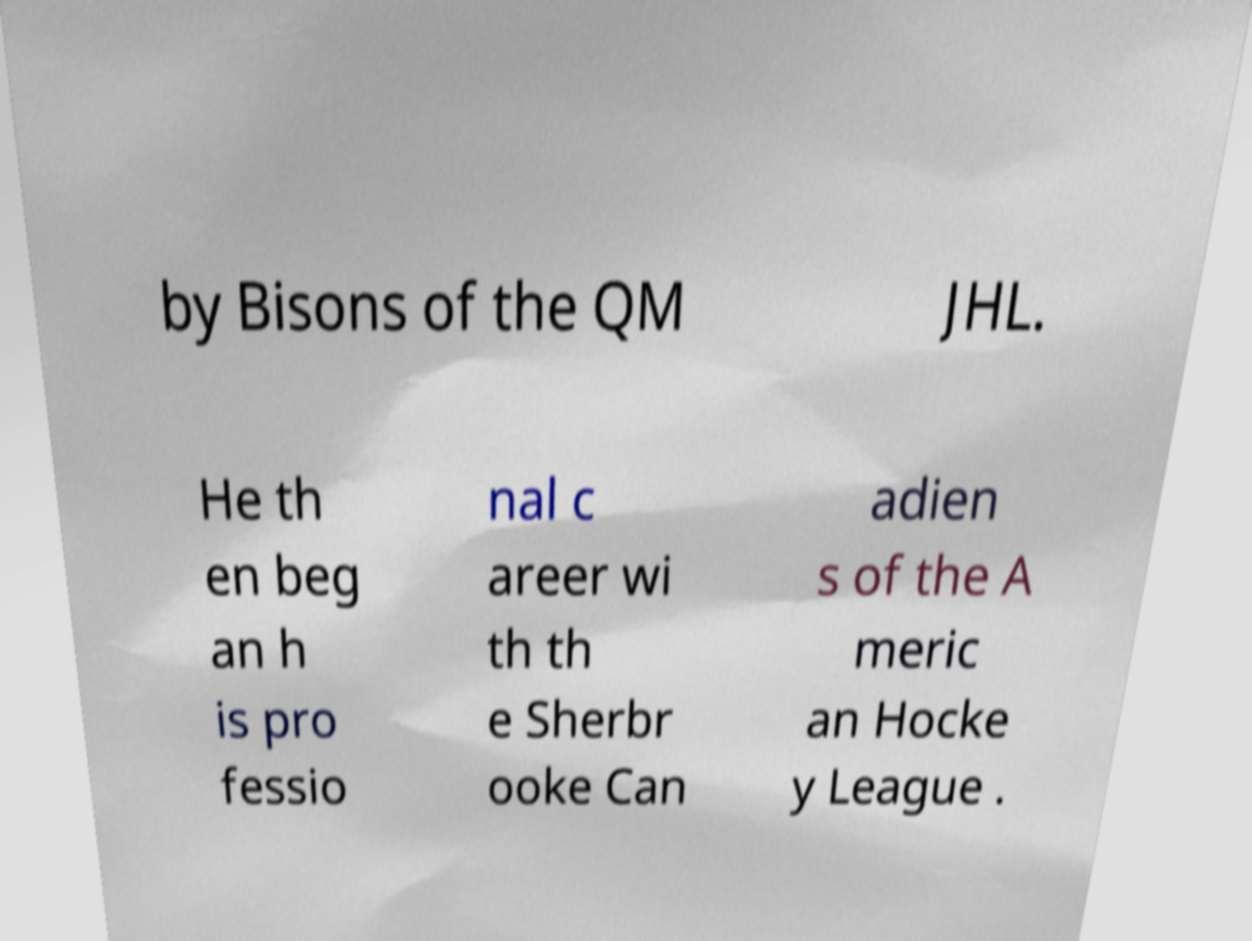What messages or text are displayed in this image? I need them in a readable, typed format. by Bisons of the QM JHL. He th en beg an h is pro fessio nal c areer wi th th e Sherbr ooke Can adien s of the A meric an Hocke y League . 